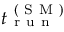Convert formula to latex. <formula><loc_0><loc_0><loc_500><loc_500>t _ { r u n } ^ { ( S M ) }</formula> 